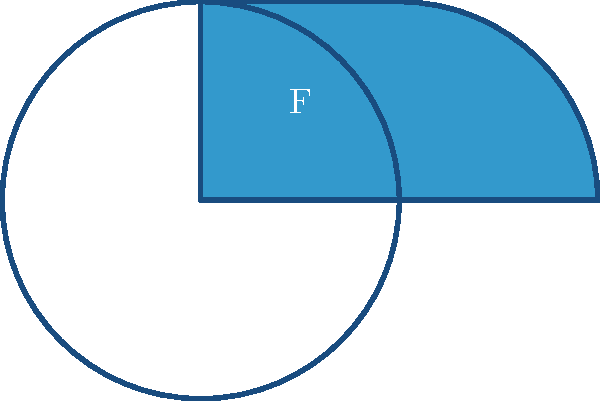A fintech startup has designed a logo consisting of a quarter circle with the letter "F" inside. What is the order of the symmetry group for this logo design? To determine the order of the symmetry group for this logo, we need to consider all possible symmetry operations that leave the logo unchanged. Let's analyze step-by-step:

1. Rotational symmetry:
   The logo has no rotational symmetry other than the identity rotation (360°), as any rotation would change its appearance.

2. Reflection symmetry:
   The logo has no lines of reflection that would leave it unchanged.

3. Identity transformation:
   The identity transformation (doing nothing) always leaves the logo unchanged.

Counting these symmetries:
- 1 identity transformation

Therefore, the symmetry group of this logo contains only one element: the identity transformation.

In group theory, the order of a group is the number of elements in the group. Since we have only one element (the identity transformation), the order of the symmetry group is 1.

This group is isomorphic to the cyclic group of order 1, often denoted as $C_1$ or $\mathbb{Z}_1$.
Answer: 1 